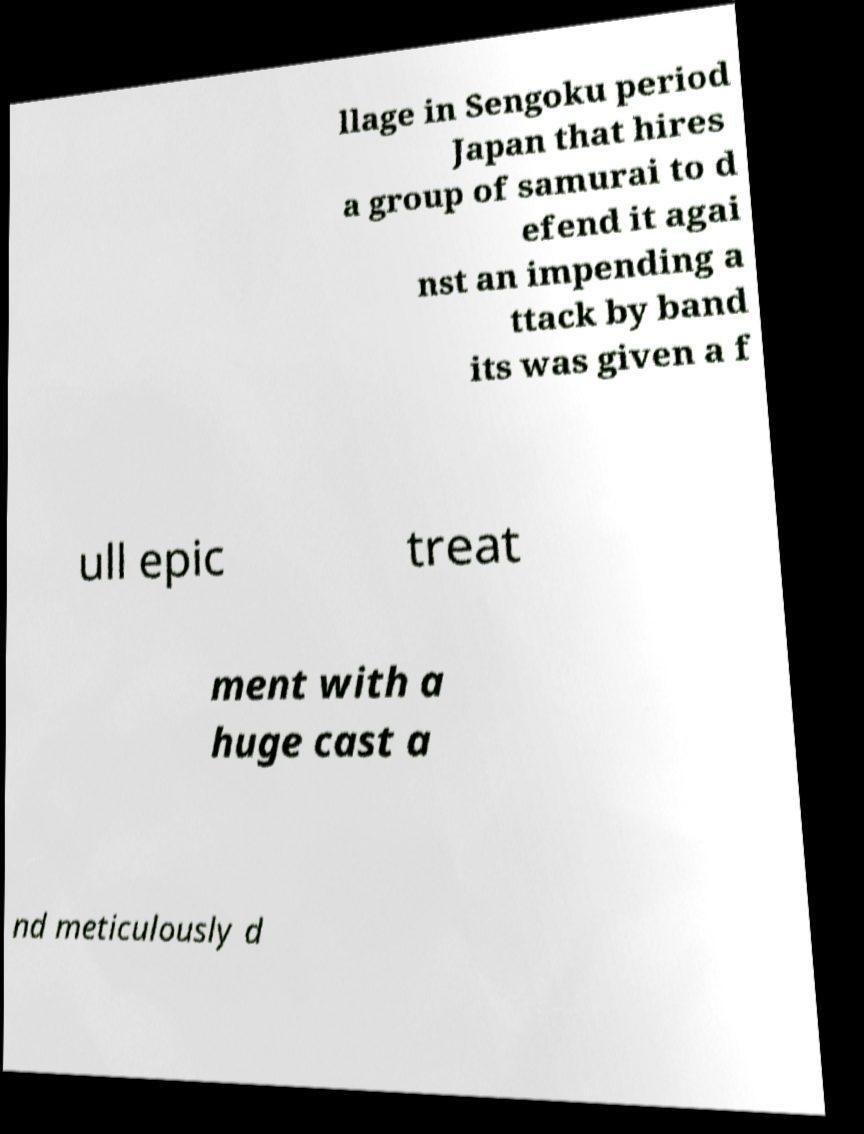Could you assist in decoding the text presented in this image and type it out clearly? llage in Sengoku period Japan that hires a group of samurai to d efend it agai nst an impending a ttack by band its was given a f ull epic treat ment with a huge cast a nd meticulously d 